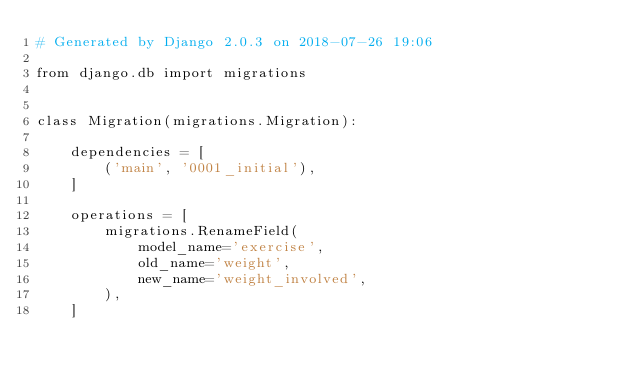Convert code to text. <code><loc_0><loc_0><loc_500><loc_500><_Python_># Generated by Django 2.0.3 on 2018-07-26 19:06

from django.db import migrations


class Migration(migrations.Migration):

    dependencies = [
        ('main', '0001_initial'),
    ]

    operations = [
        migrations.RenameField(
            model_name='exercise',
            old_name='weight',
            new_name='weight_involved',
        ),
    ]
</code> 